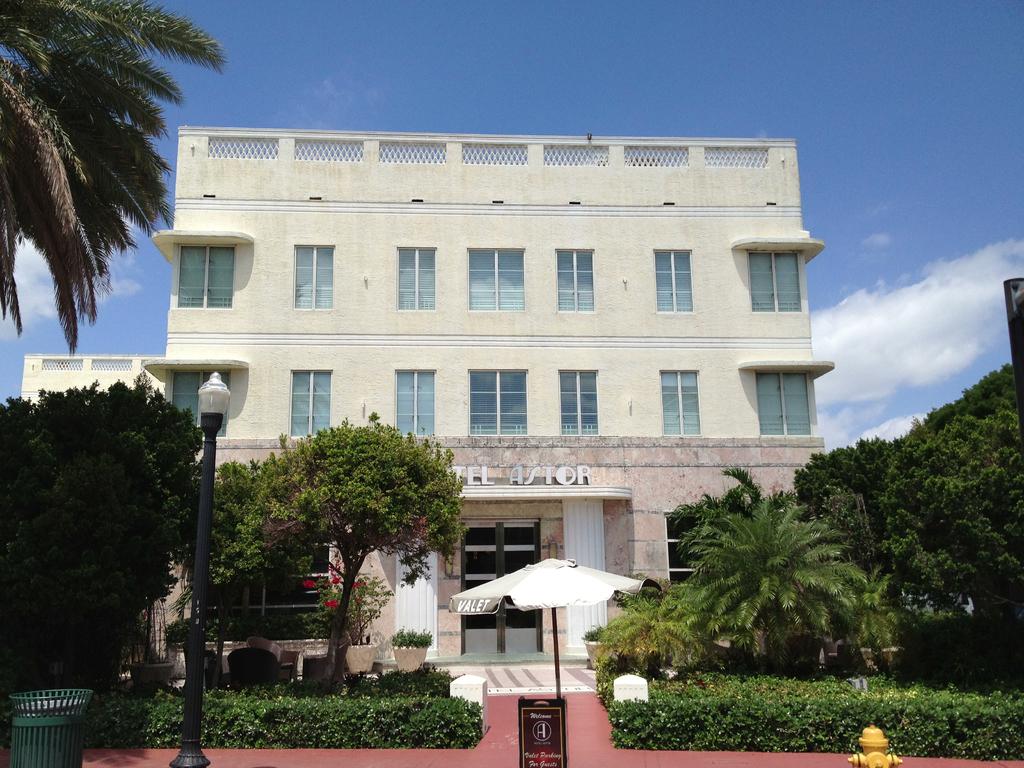What is written on the umbrella in the front?
Your answer should be compact. Valet. What's the name of the store?
Your answer should be compact. Hotel astor. 